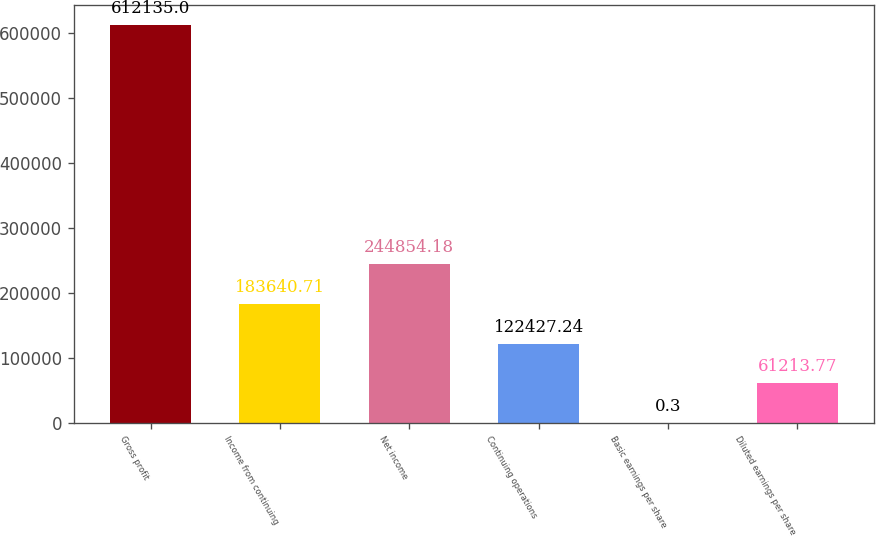Convert chart. <chart><loc_0><loc_0><loc_500><loc_500><bar_chart><fcel>Gross profit<fcel>Income from continuing<fcel>Net income<fcel>Continuing operations<fcel>Basic earnings per share<fcel>Diluted earnings per share<nl><fcel>612135<fcel>183641<fcel>244854<fcel>122427<fcel>0.3<fcel>61213.8<nl></chart> 